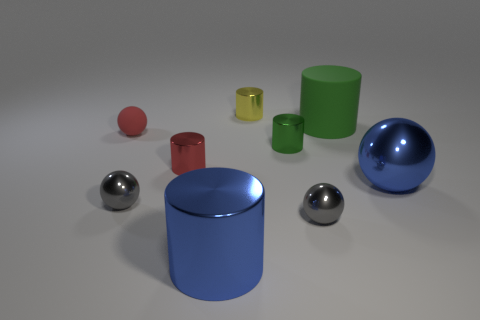Subtract 2 cylinders. How many cylinders are left? 3 Subtract all yellow cylinders. How many cylinders are left? 4 Subtract all blue cylinders. How many cylinders are left? 4 Subtract all blue cylinders. Subtract all red cubes. How many cylinders are left? 4 Subtract all balls. How many objects are left? 5 Add 9 tiny red cylinders. How many tiny red cylinders exist? 10 Subtract 1 blue balls. How many objects are left? 8 Subtract all small red rubber objects. Subtract all tiny brown rubber cylinders. How many objects are left? 8 Add 5 green metallic things. How many green metallic things are left? 6 